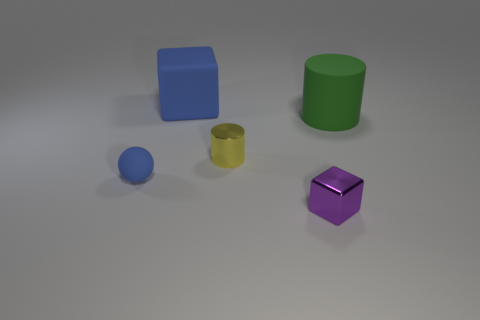Is there any other thing that has the same size as the green rubber cylinder? Considering the objects visible in the image, the blue ball appears to be roughly similar in size to the green cylinder's height but not its volume. Accurate comparisons would require knowing the exact dimensions of each object. 